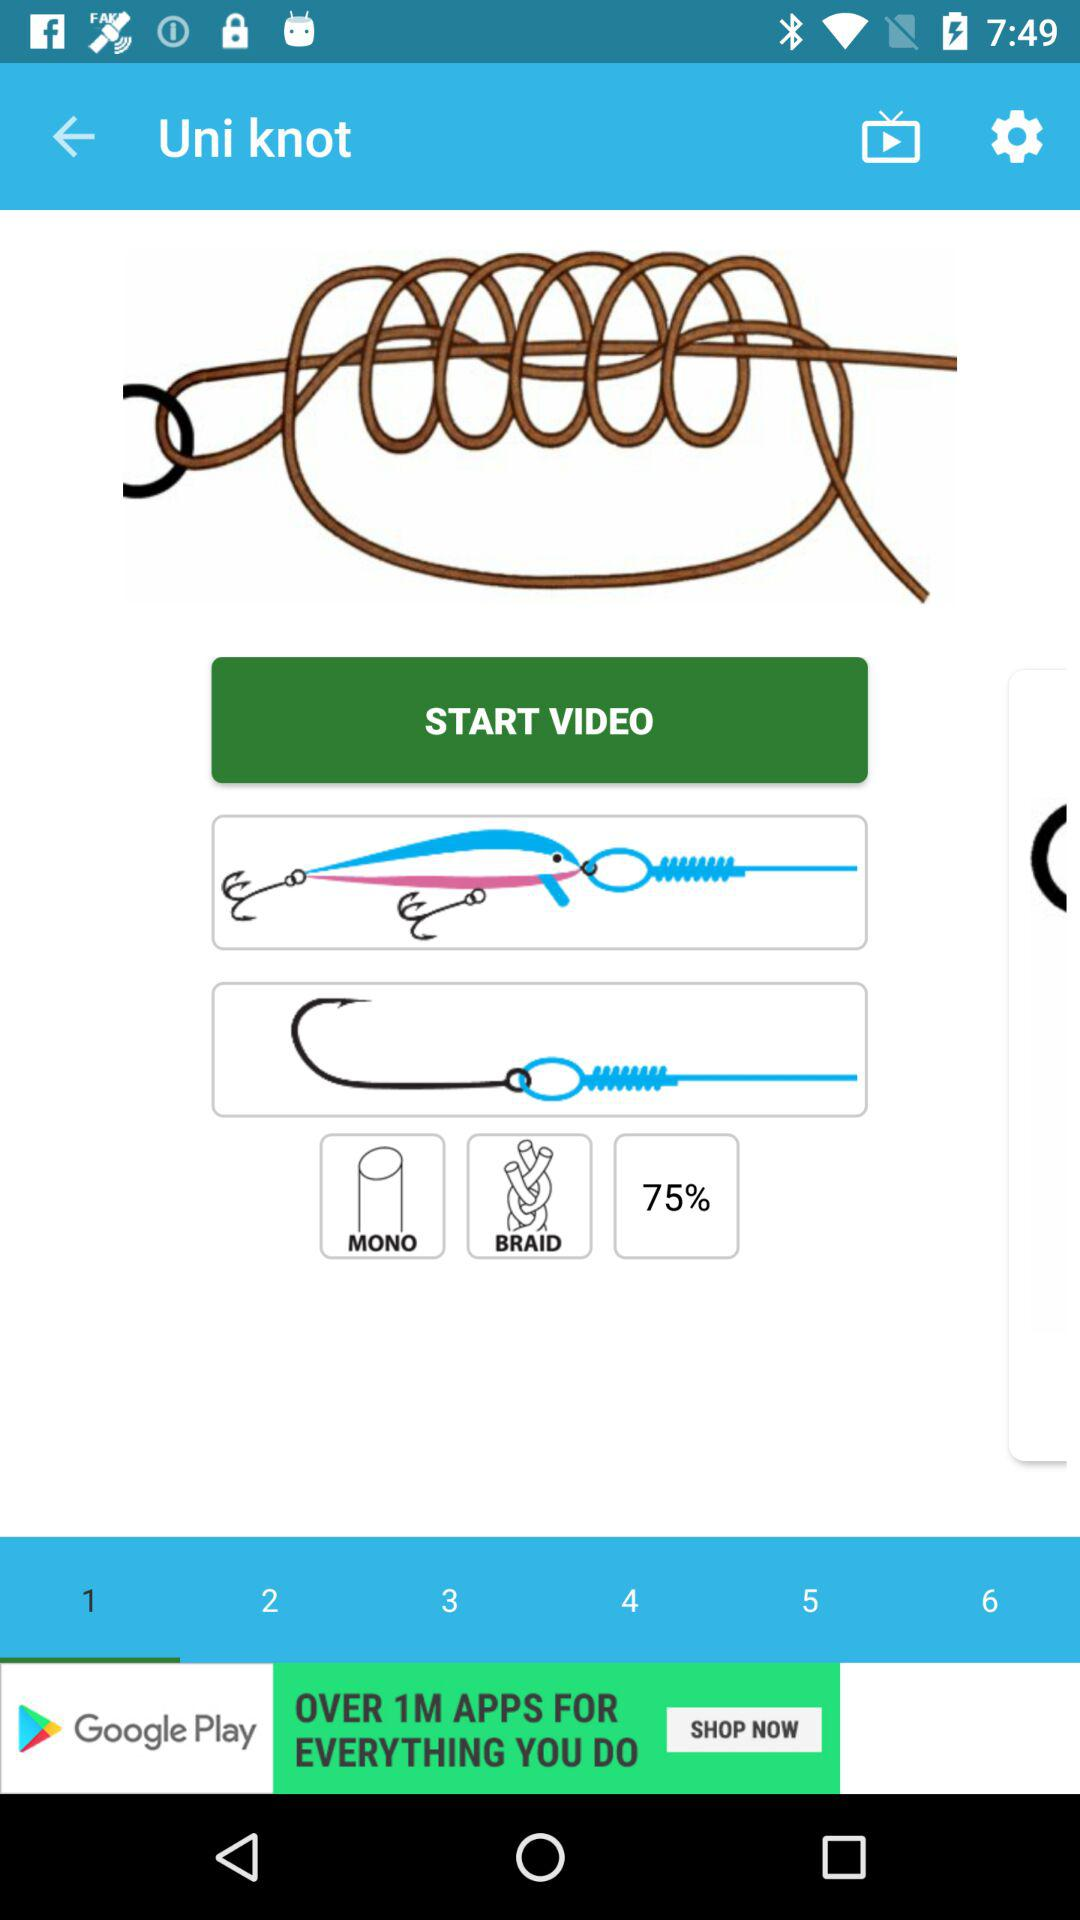What are the names of the knots? The name of the knot is "Uni knot". 